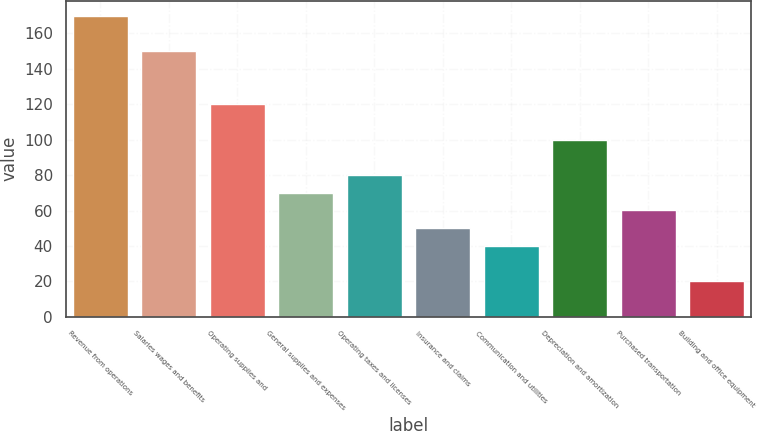Convert chart to OTSL. <chart><loc_0><loc_0><loc_500><loc_500><bar_chart><fcel>Revenue from operations<fcel>Salaries wages and benefits<fcel>Operating supplies and<fcel>General supplies and expenses<fcel>Operating taxes and licenses<fcel>Insurance and claims<fcel>Communication and utilities<fcel>Depreciation and amortization<fcel>Purchased transportation<fcel>Building and office equipment<nl><fcel>169.93<fcel>149.95<fcel>119.98<fcel>70.03<fcel>80.02<fcel>50.05<fcel>40.06<fcel>100<fcel>60.04<fcel>20.08<nl></chart> 